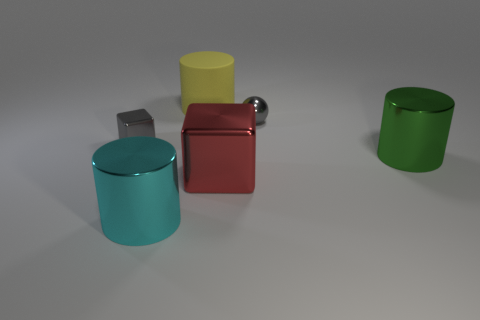The large shiny object on the left side of the red shiny thing has what shape? The large shiny object to the left of the red one is a cylinder. Its circular base and elongated structure are characteristic features of cylindrical shapes, which are often found in various objects around us. 